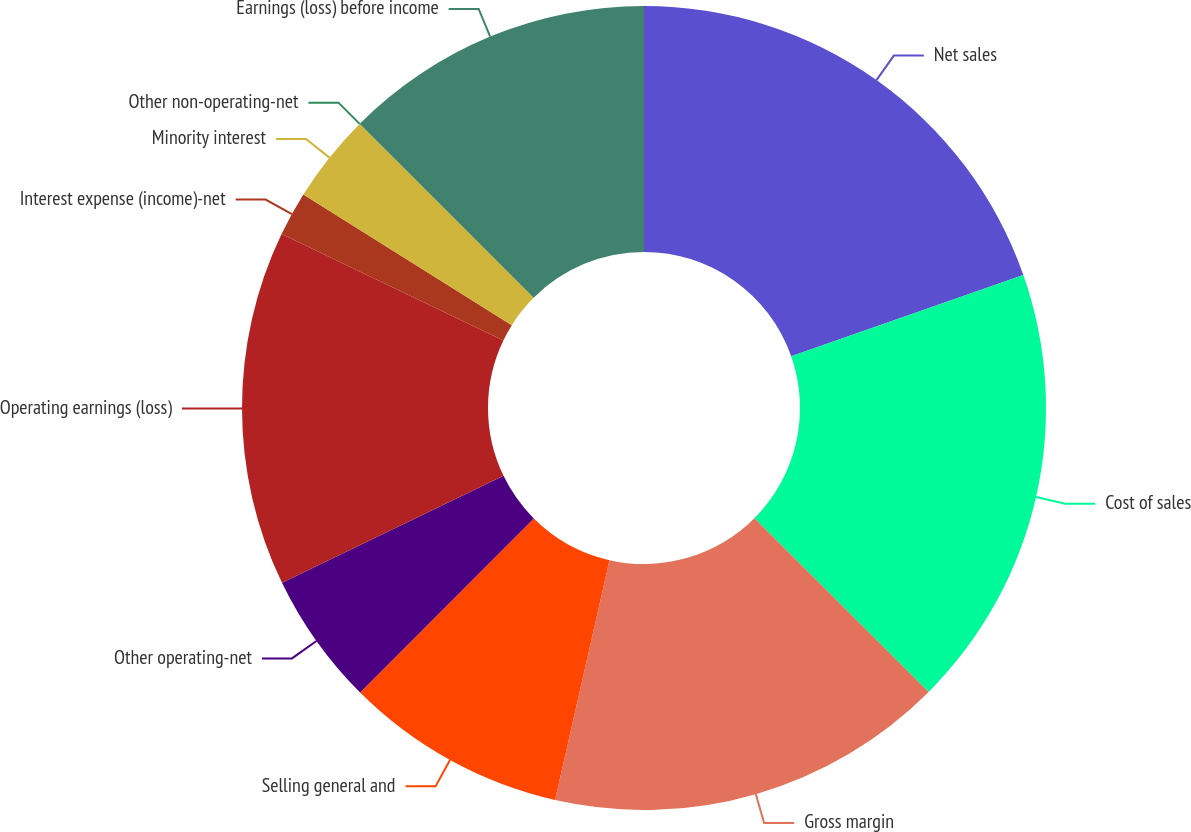Convert chart to OTSL. <chart><loc_0><loc_0><loc_500><loc_500><pie_chart><fcel>Net sales<fcel>Cost of sales<fcel>Gross margin<fcel>Selling general and<fcel>Other operating-net<fcel>Operating earnings (loss)<fcel>Interest expense (income)-net<fcel>Minority interest<fcel>Other non-operating-net<fcel>Earnings (loss) before income<nl><fcel>19.63%<fcel>17.85%<fcel>16.07%<fcel>8.93%<fcel>5.36%<fcel>14.28%<fcel>1.79%<fcel>3.58%<fcel>0.01%<fcel>12.5%<nl></chart> 